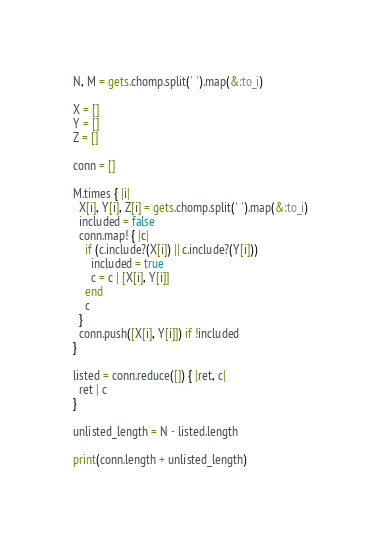Convert code to text. <code><loc_0><loc_0><loc_500><loc_500><_Ruby_>N, M = gets.chomp.split(' ').map(&:to_i)

X = []
Y = []
Z = []

conn = []

M.times { |i|
  X[i], Y[i], Z[i] = gets.chomp.split(' ').map(&:to_i)
  included = false
  conn.map! { |c|
    if (c.include?(X[i]) || c.include?(Y[i]))
      included = true
      c = c | [X[i], Y[i]]
    end
    c
  }
  conn.push([X[i], Y[i]]) if !included
}

listed = conn.reduce([]) { |ret, c|
  ret | c
}

unlisted_length = N - listed.length

print(conn.length + unlisted_length)
</code> 